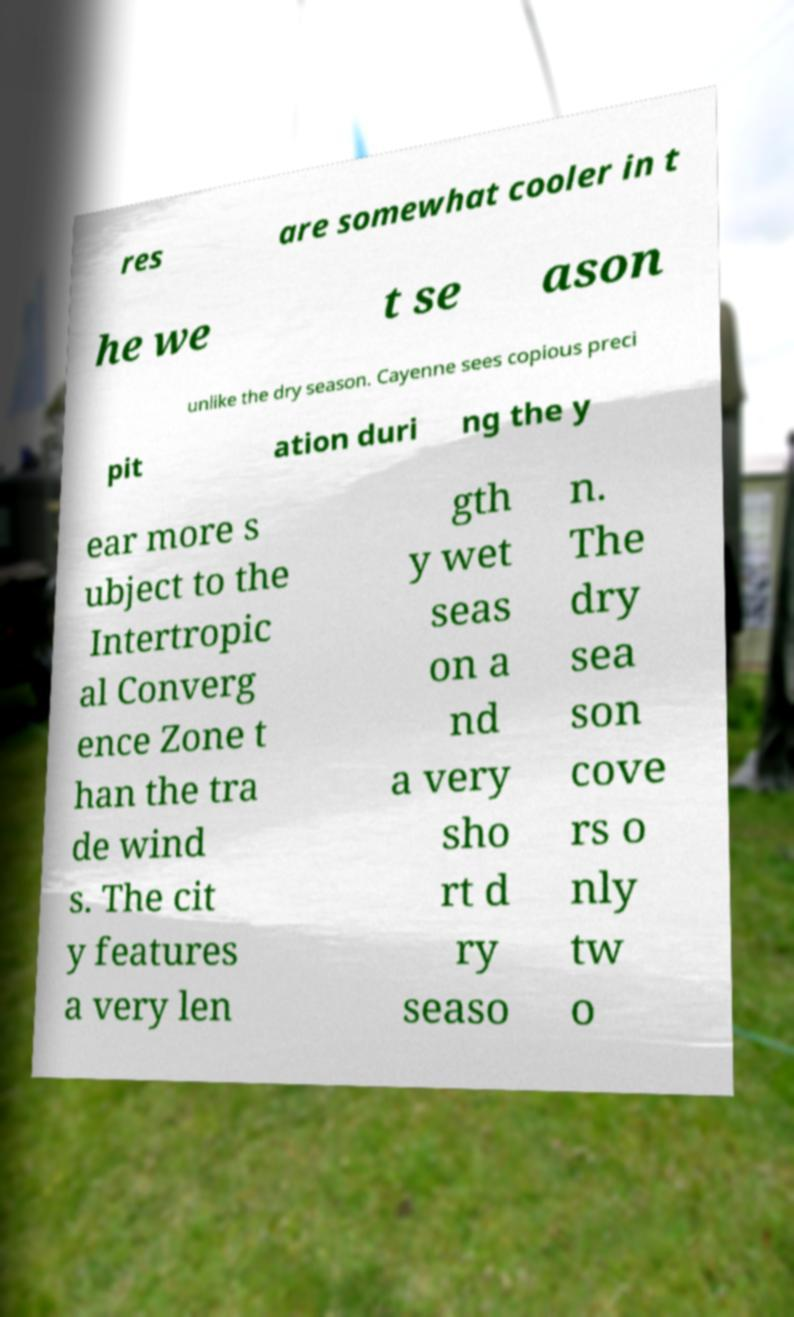Please identify and transcribe the text found in this image. res are somewhat cooler in t he we t se ason unlike the dry season. Cayenne sees copious preci pit ation duri ng the y ear more s ubject to the Intertropic al Converg ence Zone t han the tra de wind s. The cit y features a very len gth y wet seas on a nd a very sho rt d ry seaso n. The dry sea son cove rs o nly tw o 